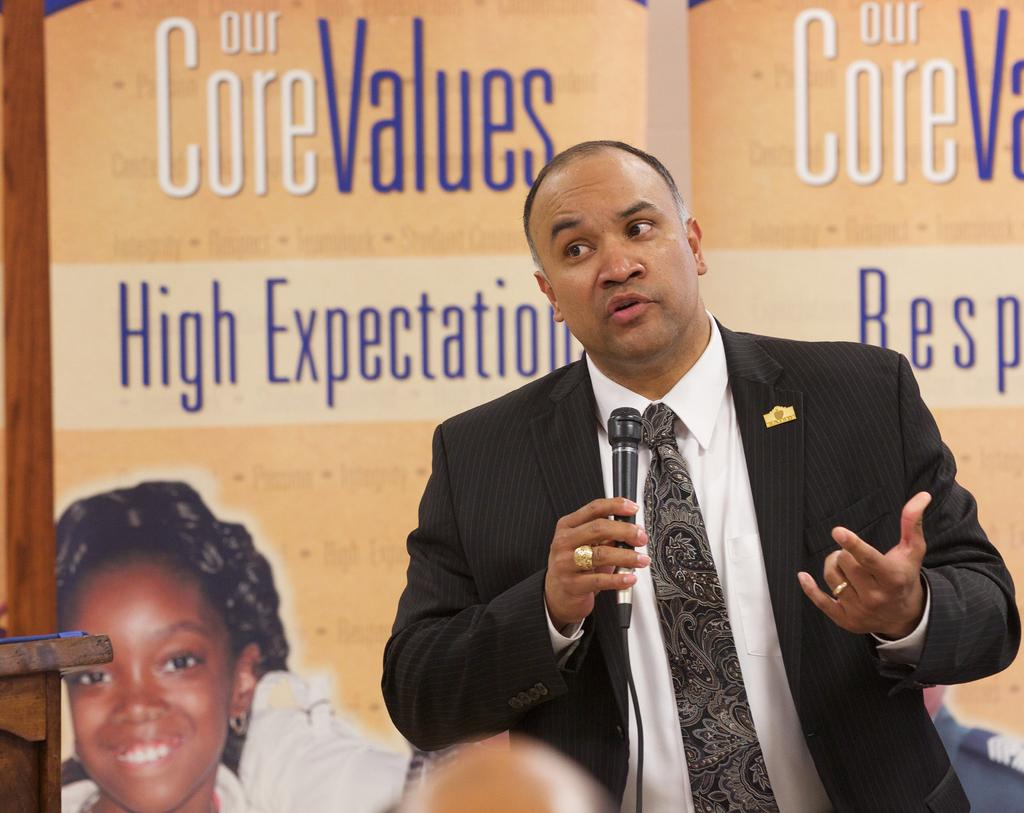What is the main subject of the image? There is a man standing in the center of the image. What is the man holding in his hand? The man is holding a mic in his hand. What can be seen in the background of the image? There is a board in the background of the image. What is located on the left side of the image? There is a table on the left side of the image. How many holes can be seen in the notebook on the table? There is no notebook present in the image; only a table is mentioned. 